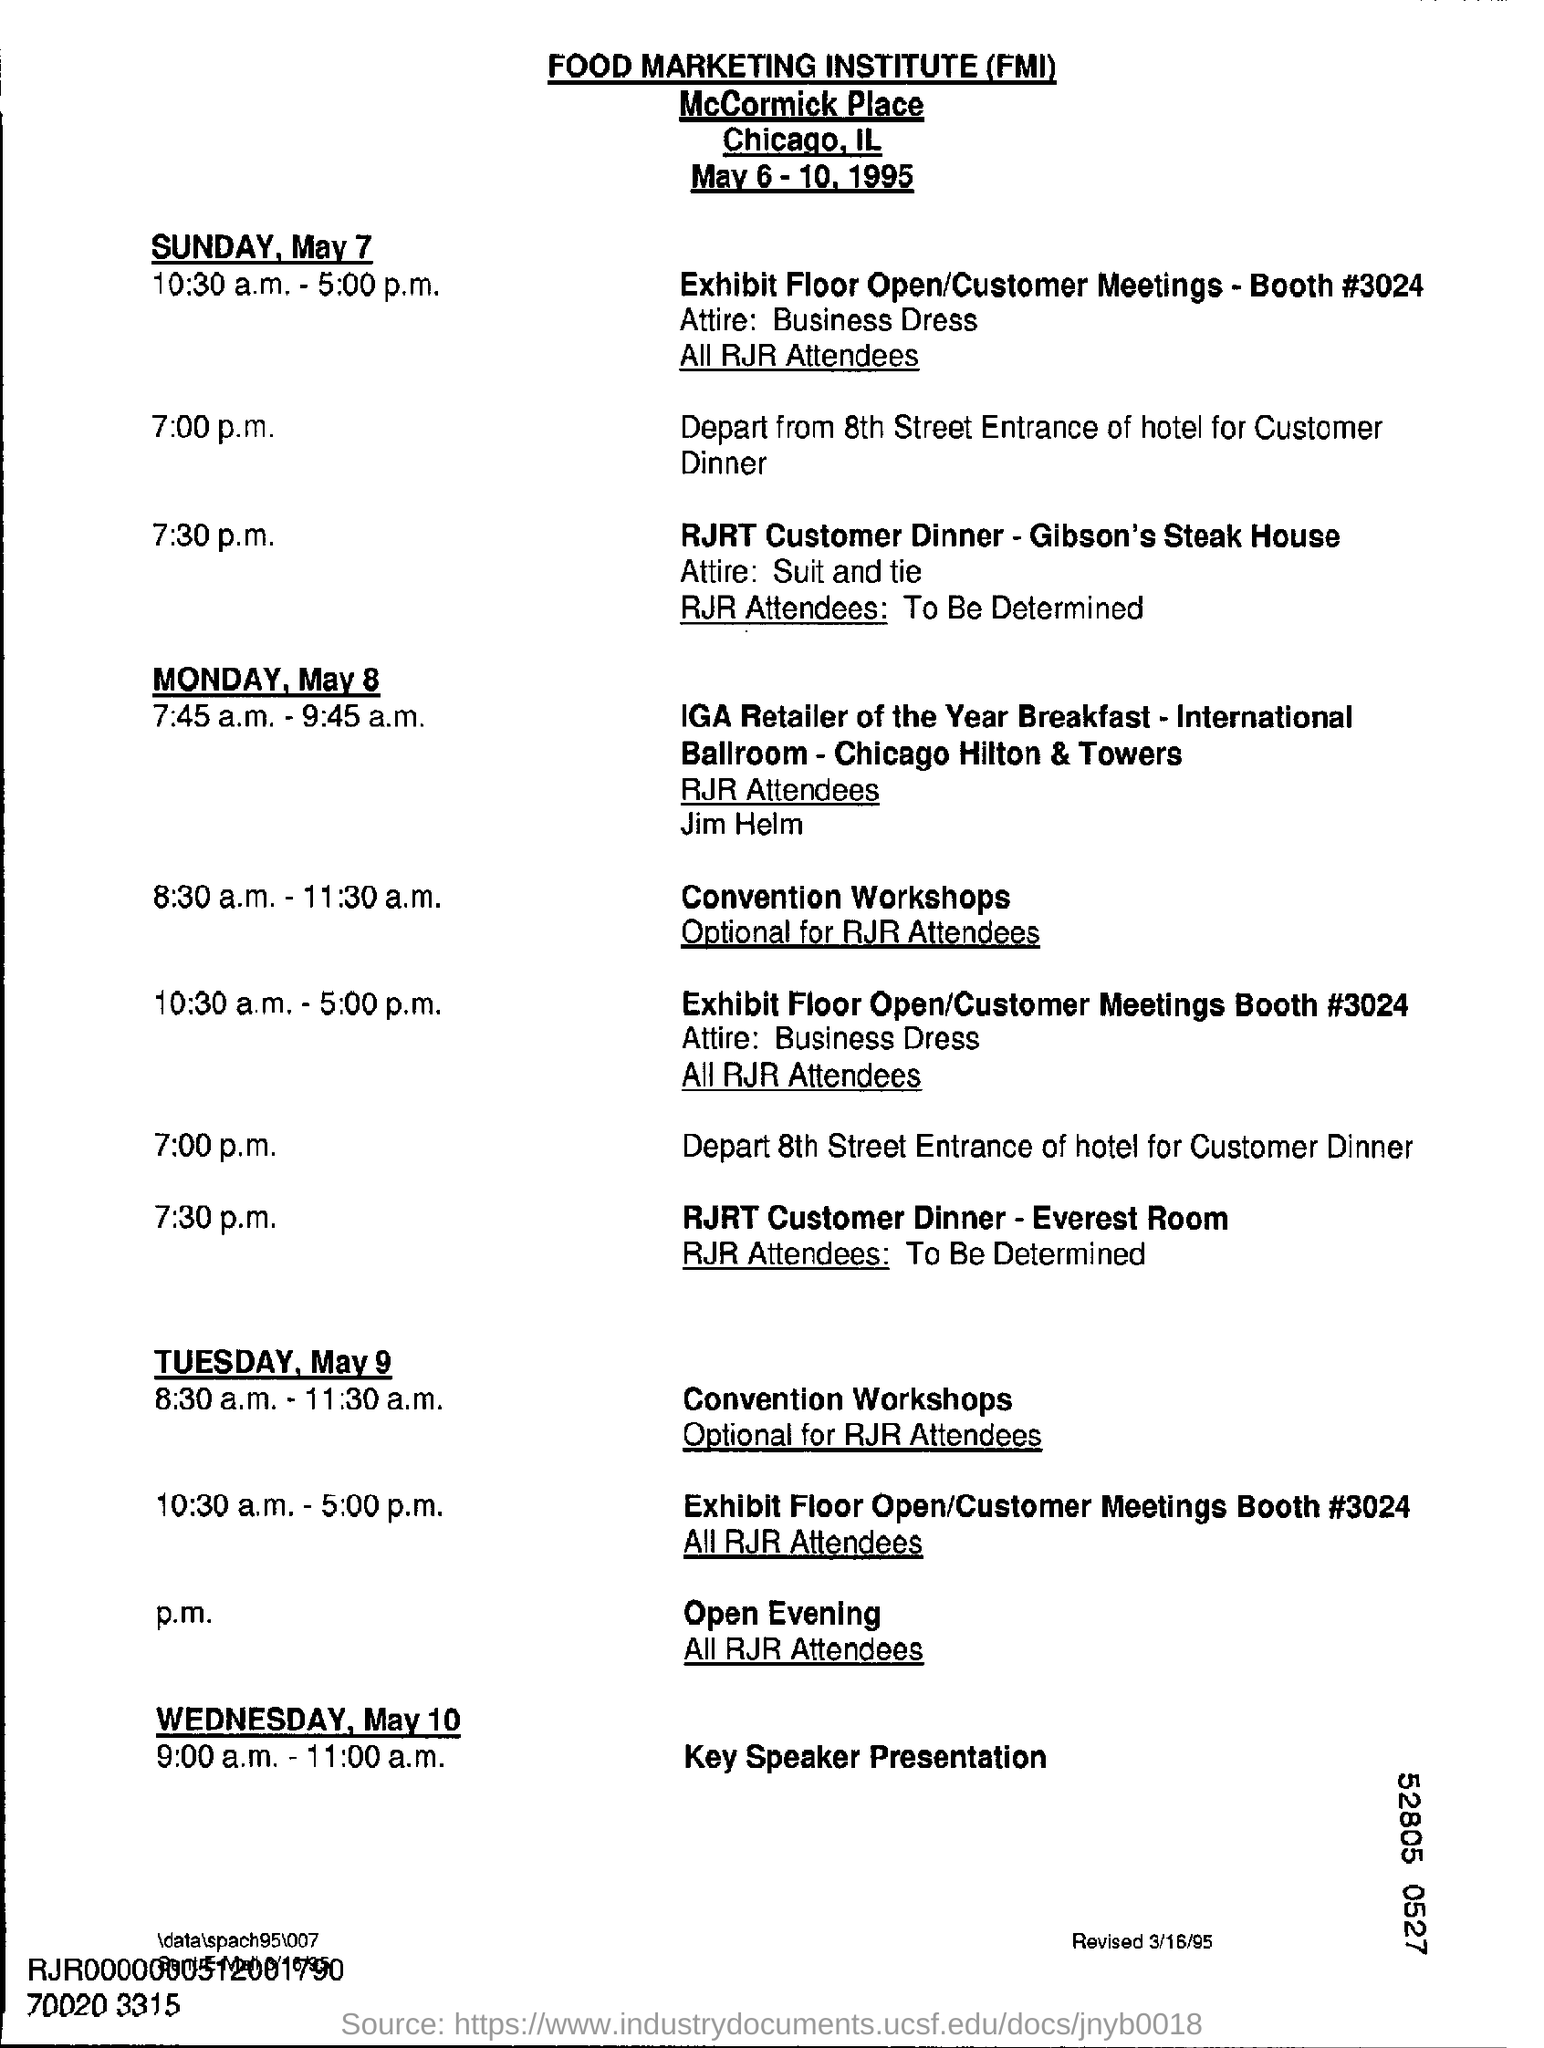List a handful of essential elements in this visual. The dress code for the dinner is business attire, specifically a suit and tie. The RJRT Customer Dinner for Sunday, May 7, will be held at Gibson's Steak House. The full form of FMI is Food Marketing Institute. The attendees for the IGA Retailer of the Year Breakfast held on Monday, May 8, were the RJR attendees, and among them was Jim Helm. The meeting is scheduled for May 6th to May 10th, 1995. 